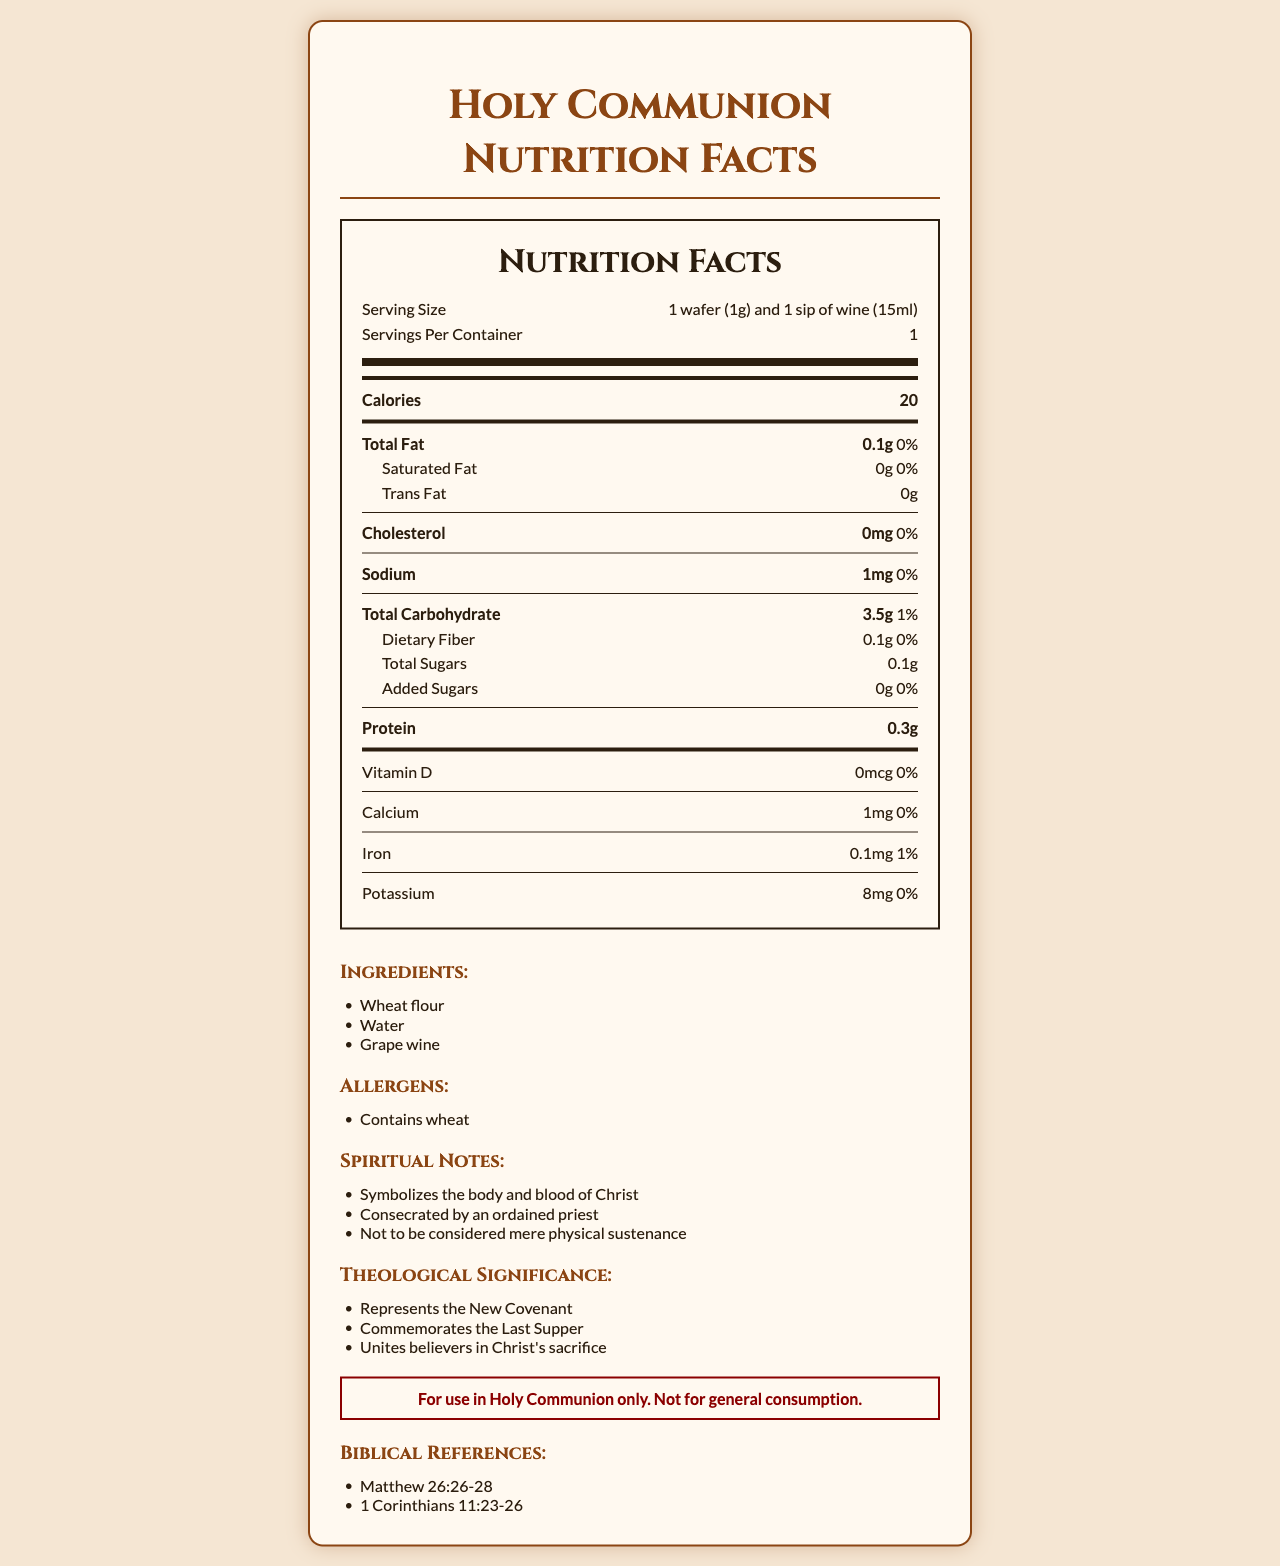what is the serving size? The serving size information is located in the "Nutrition Facts" section at the top of the document.
Answer: 1 wafer (1g) and 1 sip of wine (15ml) how many calories are in one serving? The calorie information is located in the bold "Calories" section within the "Nutrition Facts".
Answer: 20 what ingredients are used to make the communion bread and wine? The ingredients are listed under the "Ingredients" section towards the bottom of the document.
Answer: Wheat flour, Water, Grape wine what is the total carbohydrate content in one serving? The total carbohydrate content is listed in the "Total Carbohydrate" section under "Nutrition Facts".
Answer: 3.5g are there any common allergens in this communion bread and wine? The "Allergens" section states that the product contains wheat.
Answer: Yes how many grams of protein are there per serving? The protein content is listed within the "Nutrition Facts".
Answer: 0.3g what is the calcium content in one serving? A. 0mg B. 1mg C. 100mg The calcium content is listed as 1mg in the document.
Answer: B how much sodium does one serving contain? A. 1mg B. 10mg C. 100mg The sodium content is listed as 1mg in the document.
Answer: A is there any added sugar in a serving of this communion bread and wine? The amount of added sugars is listed as 0g in the "Nutrition Facts".
Answer: No is this communion bread and wine intended for general consumption? The document contains a "sacramental warning" that states the items are for use in Holy Communion only and not for general consumption.
Answer: No what does this communion bread and wine symbolize? The "Spiritual Notes" section indicates that the bread and wine symbolize the body and blood of Christ.
Answer: The body and blood of Christ summarize the main idea of this document. The summary includes the nutritional breakdown for one serving, details the ingredients, mentions any allergens, and touches on the theological significance and appropriate use of the communion items.
Answer: This document provides nutritional information for Holy Communion bread and wine, listing ingredients, allergens, spiritual notes, theological significance, a sacramental warning, and biblical references. what is the total fiber content as a percentage of the daily value? Under the "Nutrition Facts," dietary fiber is listed as 0.1g with a daily value percentage of 0%.
Answer: 0% what biblical references are mentioned in the document? The biblical references are listed at the bottom of the document under "Biblical References".
Answer: Matthew 26:26-28, 1 Corinthians 11:23-26 is there any cholesterol in this communion serving? The "Nutrition Facts" section lists cholesterol as 0mg, indicating there is no cholesterol.
Answer: No how many servings are there per container? The serving information at the top of the "Nutrition Facts" mentions that there is 1 serving per container.
Answer: 1 how much iron is there in each serving as a percentage of the daily value? The iron content is listed as 0.1mg with a daily value of 1%.
Answer: 1% how is the communion bread and wine to be consecrated? The "Spiritual Notes" section states that the bread and wine are to be consecrated by an ordained priest.
Answer: By an ordained priest what is the purpose of the sacramental warning in this document? The "Sacramental Warning" section lists this specific purpose clearly.
Answer: To emphasize that the communion bread and wine are only for use in Holy Communion and not for general consumption what specific protein source is indicated in the ingredients? The document lists "Wheat flour, Water, Grape wine" as the ingredients, but does not specify which one contributes to the 0.3g of protein per serving.
Answer: Not enough information 